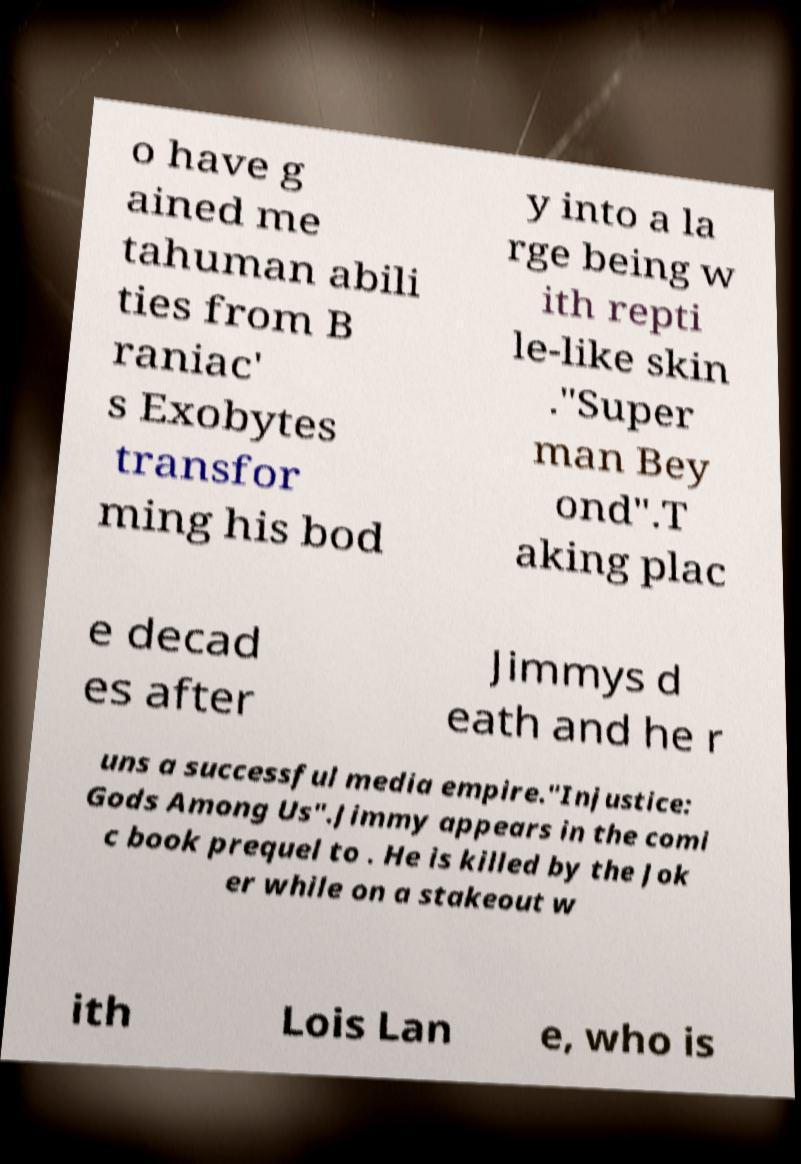Could you assist in decoding the text presented in this image and type it out clearly? o have g ained me tahuman abili ties from B raniac' s Exobytes transfor ming his bod y into a la rge being w ith repti le-like skin ."Super man Bey ond".T aking plac e decad es after Jimmys d eath and he r uns a successful media empire."Injustice: Gods Among Us".Jimmy appears in the comi c book prequel to . He is killed by the Jok er while on a stakeout w ith Lois Lan e, who is 